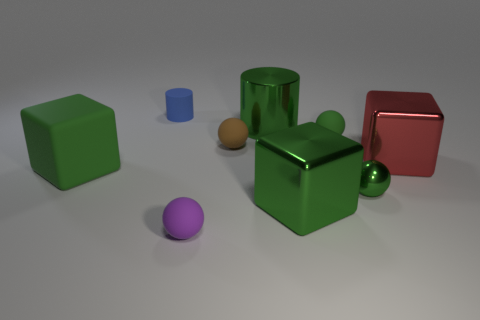There is a ball that is behind the rubber block and on the right side of the brown sphere; what color is it?
Your answer should be very brief. Green. There is a brown matte thing; does it have the same size as the green rubber thing on the left side of the brown ball?
Your answer should be very brief. No. There is another large shiny thing that is the same shape as the blue thing; what is its color?
Your response must be concise. Green. Do the green metallic sphere and the purple thing have the same size?
Make the answer very short. Yes. How many other things are the same size as the green cylinder?
Give a very brief answer. 3. What number of objects are either big shiny blocks right of the green rubber ball or big green cubes that are on the right side of the blue cylinder?
Your answer should be compact. 2. There is a purple matte thing that is the same size as the green rubber sphere; what shape is it?
Make the answer very short. Sphere. There is a purple ball that is made of the same material as the small blue cylinder; what size is it?
Offer a very short reply. Small. Do the big green rubber thing and the large red object have the same shape?
Provide a short and direct response. Yes. There is a metallic ball that is the same size as the brown rubber sphere; what is its color?
Keep it short and to the point. Green. 